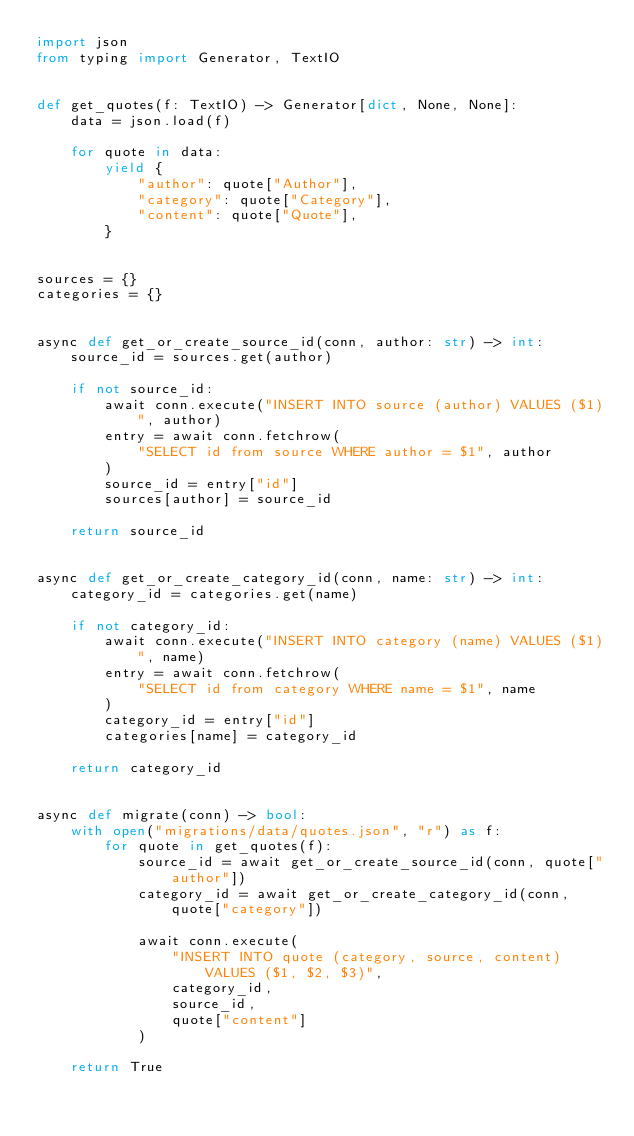Convert code to text. <code><loc_0><loc_0><loc_500><loc_500><_Python_>import json
from typing import Generator, TextIO


def get_quotes(f: TextIO) -> Generator[dict, None, None]:
    data = json.load(f)

    for quote in data:
        yield {
            "author": quote["Author"],
            "category": quote["Category"],
            "content": quote["Quote"],
        }


sources = {}
categories = {}


async def get_or_create_source_id(conn, author: str) -> int:
    source_id = sources.get(author)

    if not source_id:
        await conn.execute("INSERT INTO source (author) VALUES ($1)", author)
        entry = await conn.fetchrow(
            "SELECT id from source WHERE author = $1", author
        )
        source_id = entry["id"]
        sources[author] = source_id

    return source_id


async def get_or_create_category_id(conn, name: str) -> int:
    category_id = categories.get(name)

    if not category_id:
        await conn.execute("INSERT INTO category (name) VALUES ($1)", name)
        entry = await conn.fetchrow(
            "SELECT id from category WHERE name = $1", name
        )
        category_id = entry["id"]
        categories[name] = category_id

    return category_id


async def migrate(conn) -> bool:
    with open("migrations/data/quotes.json", "r") as f:
        for quote in get_quotes(f):
            source_id = await get_or_create_source_id(conn, quote["author"])
            category_id = await get_or_create_category_id(conn, quote["category"])

            await conn.execute(
                "INSERT INTO quote (category, source, content) VALUES ($1, $2, $3)",
                category_id,
                source_id,
                quote["content"]
            )

    return True
</code> 